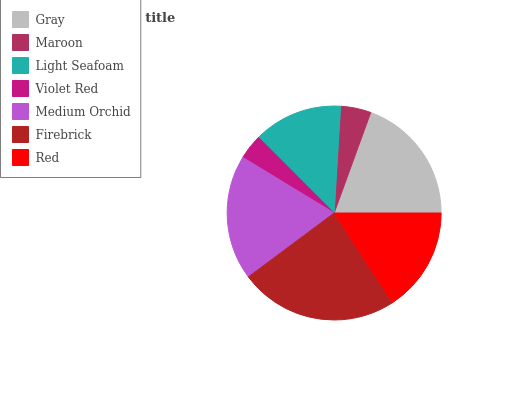Is Violet Red the minimum?
Answer yes or no. Yes. Is Firebrick the maximum?
Answer yes or no. Yes. Is Maroon the minimum?
Answer yes or no. No. Is Maroon the maximum?
Answer yes or no. No. Is Gray greater than Maroon?
Answer yes or no. Yes. Is Maroon less than Gray?
Answer yes or no. Yes. Is Maroon greater than Gray?
Answer yes or no. No. Is Gray less than Maroon?
Answer yes or no. No. Is Red the high median?
Answer yes or no. Yes. Is Red the low median?
Answer yes or no. Yes. Is Maroon the high median?
Answer yes or no. No. Is Maroon the low median?
Answer yes or no. No. 